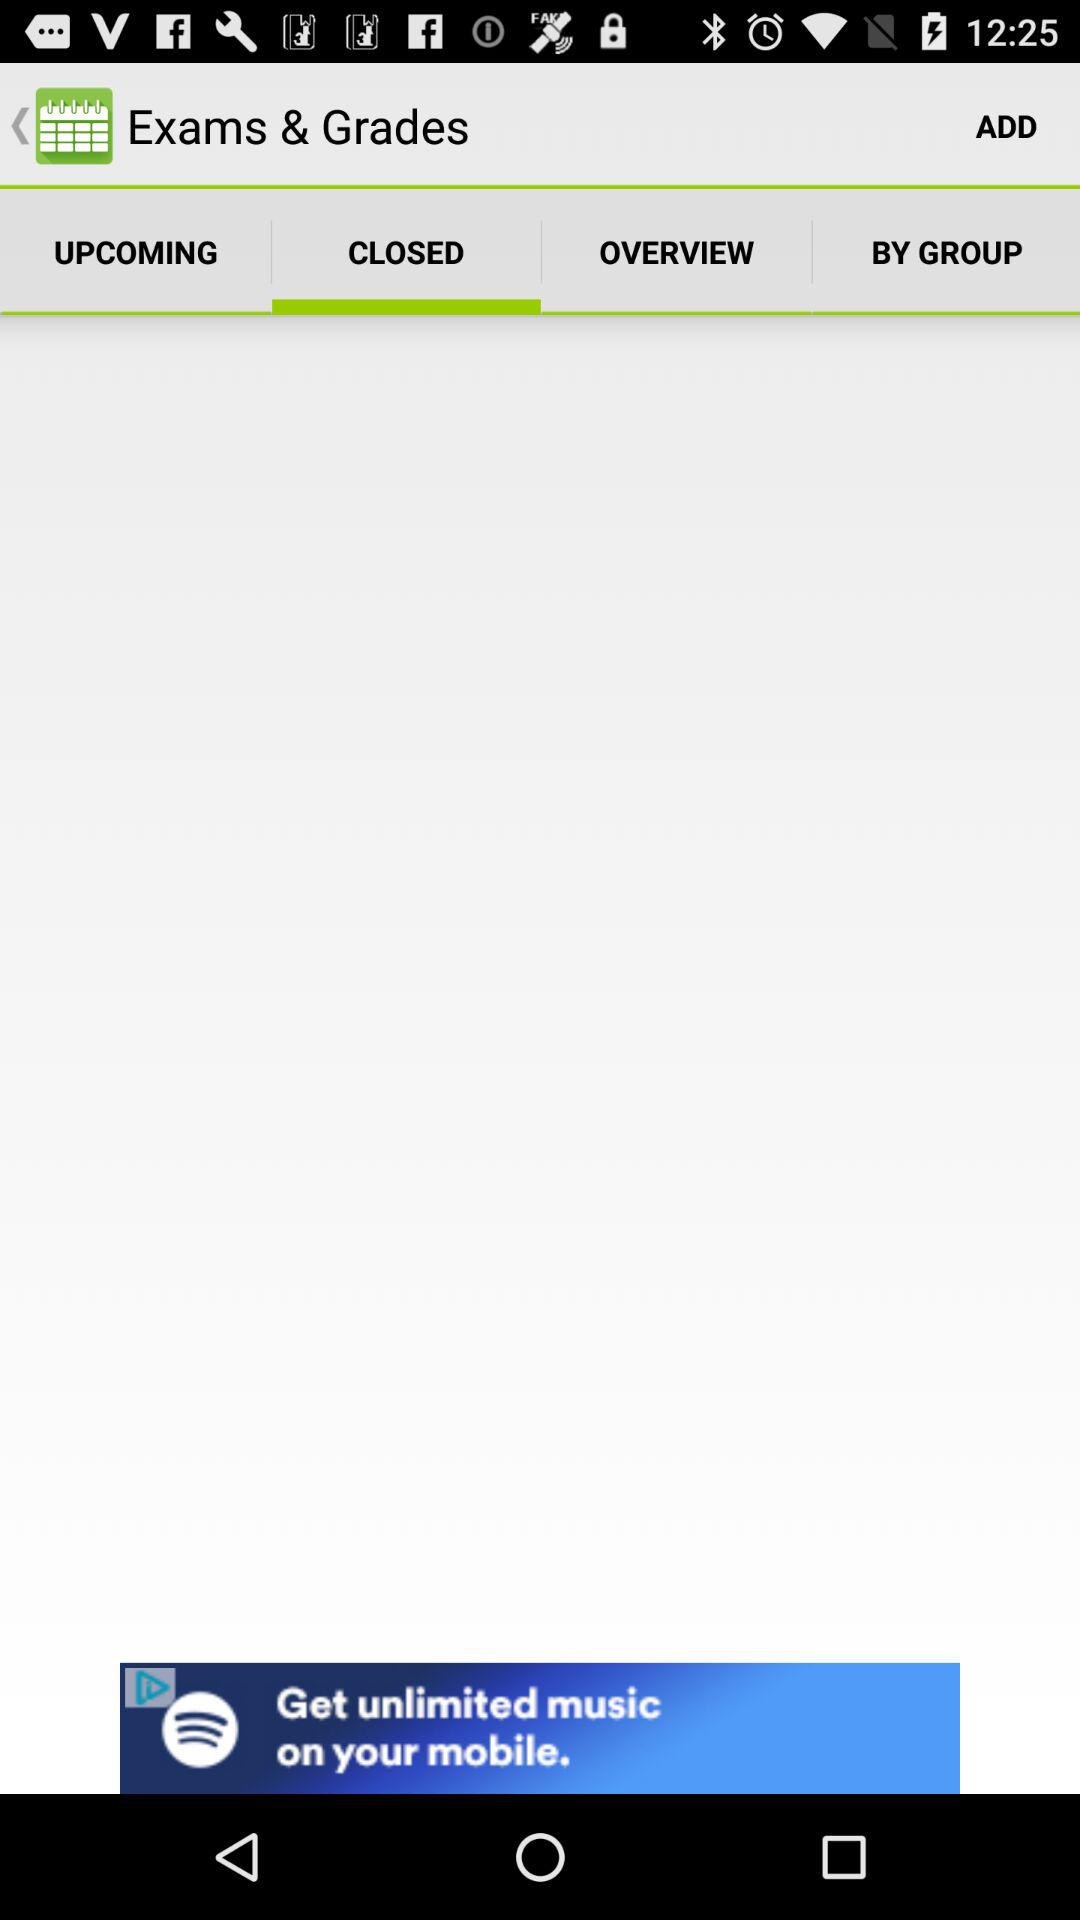What is the selected option? The selected option is "CLOSED". 